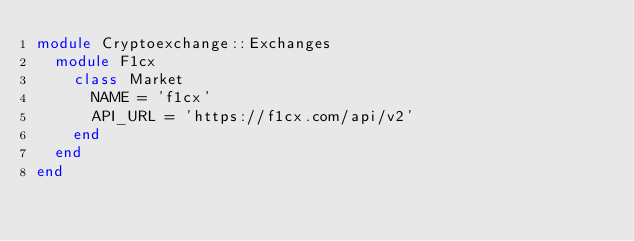Convert code to text. <code><loc_0><loc_0><loc_500><loc_500><_Ruby_>module Cryptoexchange::Exchanges
  module F1cx
    class Market
      NAME = 'f1cx'
      API_URL = 'https://f1cx.com/api/v2'
    end
  end
end
</code> 